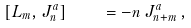<formula> <loc_0><loc_0><loc_500><loc_500>[ L _ { m } , J _ { n } ^ { a } ] \quad = - n \, J _ { n + m } ^ { a } \, ,</formula> 